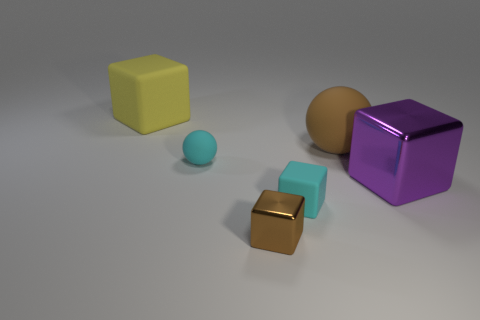There is a block right of the large matte sphere; does it have the same color as the large rubber block?
Provide a succinct answer. No. The matte thing that is both to the right of the brown shiny thing and on the left side of the large sphere is what color?
Keep it short and to the point. Cyan. There is a yellow thing that is the same size as the purple object; what shape is it?
Your answer should be compact. Cube. Are there any tiny cyan rubber things of the same shape as the tiny brown shiny thing?
Ensure brevity in your answer.  Yes. There is a brown object that is in front of the brown rubber sphere; does it have the same size as the small sphere?
Ensure brevity in your answer.  Yes. There is a rubber thing that is both behind the big shiny object and to the right of the small ball; what is its size?
Provide a succinct answer. Large. What number of other objects are the same material as the purple cube?
Offer a terse response. 1. There is a rubber block on the right side of the tiny brown object; what is its size?
Offer a terse response. Small. Does the tiny matte sphere have the same color as the large metallic thing?
Provide a succinct answer. No. What number of small things are gray objects or purple objects?
Give a very brief answer. 0. 